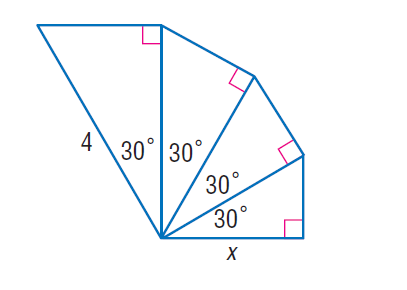Question: Each triangle in the figure is a 30 - 60 - 90 triangle. Find x.
Choices:
A. 2
B. 2.25
C. 3.5
D. 4.5
Answer with the letter. Answer: B 